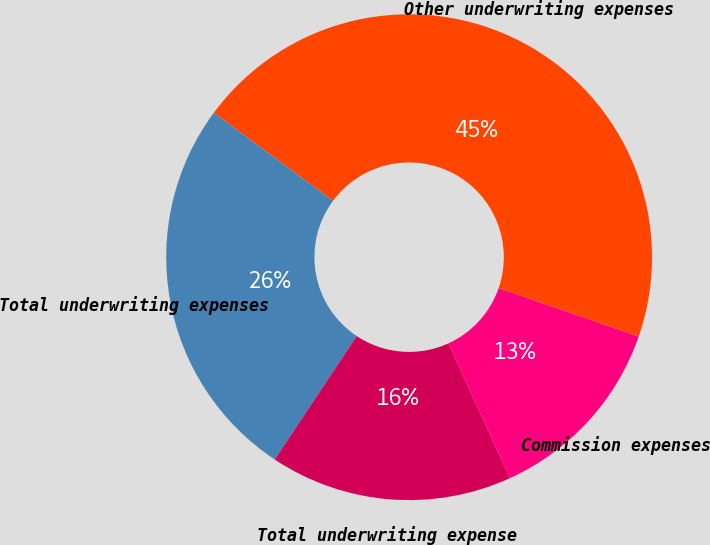Convert chart to OTSL. <chart><loc_0><loc_0><loc_500><loc_500><pie_chart><fcel>Commission expenses<fcel>Other underwriting expenses<fcel>Total underwriting expenses<fcel>Total underwriting expense<nl><fcel>12.9%<fcel>45.16%<fcel>25.81%<fcel>16.13%<nl></chart> 